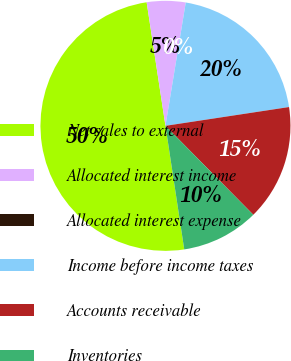Convert chart. <chart><loc_0><loc_0><loc_500><loc_500><pie_chart><fcel>Net sales to external<fcel>Allocated interest income<fcel>Allocated interest expense<fcel>Income before income taxes<fcel>Accounts receivable<fcel>Inventories<nl><fcel>49.99%<fcel>5.0%<fcel>0.0%<fcel>20.0%<fcel>15.0%<fcel>10.0%<nl></chart> 